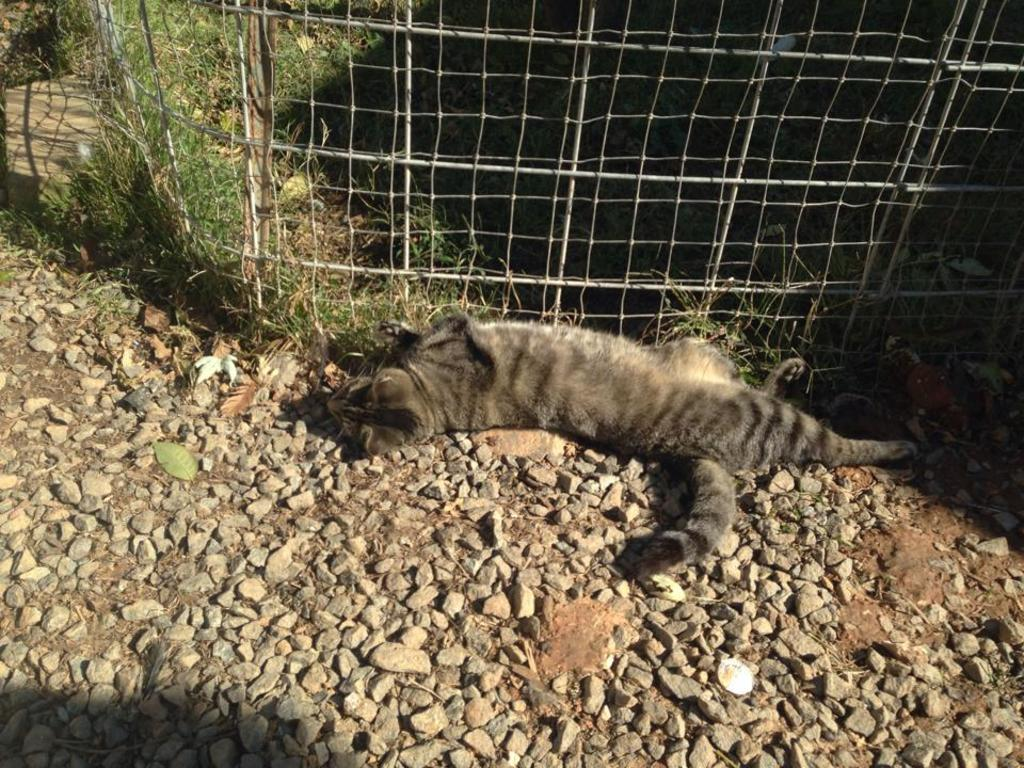What type of animal is in the image? There is a cat in the image. Can you describe the color of the cat? The cat is black and ash in color. What is the cat doing in the image? The cat is laying on the ground. What can be seen on the ground in the image? There are stones on the ground. What type of vegetation is visible in the image? There is grass visible in the image. What type of structure is present in the image? There is fencing in the image. What type of clouds can be seen in the image? There are no clouds visible in the image. What holiday is being celebrated in the image? There is no indication of a holiday being celebrated in the image. 